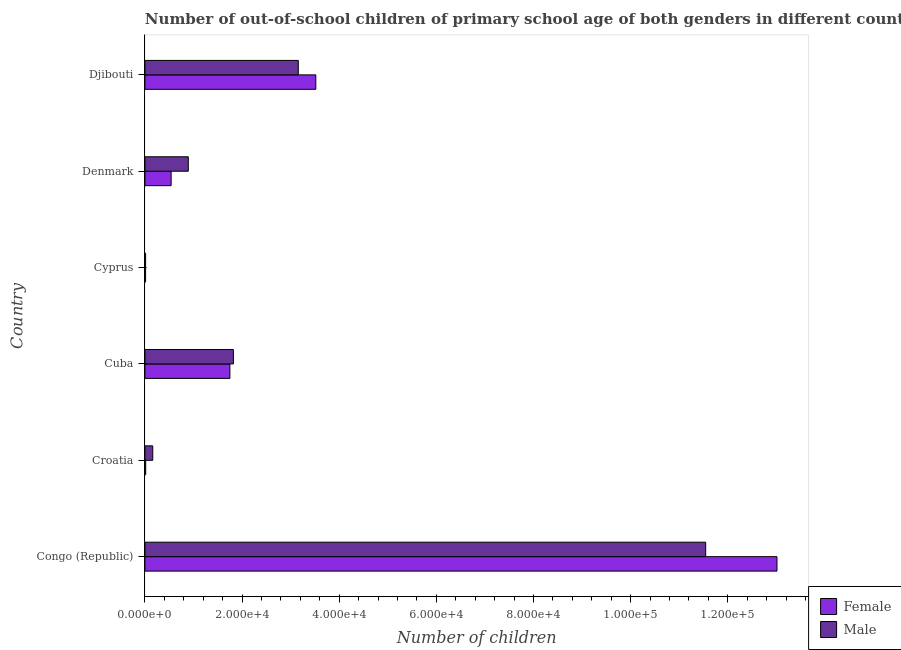How many groups of bars are there?
Provide a succinct answer. 6. Are the number of bars per tick equal to the number of legend labels?
Keep it short and to the point. Yes. What is the label of the 4th group of bars from the top?
Offer a terse response. Cuba. In how many cases, is the number of bars for a given country not equal to the number of legend labels?
Provide a short and direct response. 0. What is the number of female out-of-school students in Djibouti?
Keep it short and to the point. 3.52e+04. Across all countries, what is the maximum number of male out-of-school students?
Your answer should be compact. 1.15e+05. Across all countries, what is the minimum number of male out-of-school students?
Provide a short and direct response. 142. In which country was the number of male out-of-school students maximum?
Provide a succinct answer. Congo (Republic). In which country was the number of male out-of-school students minimum?
Your answer should be very brief. Cyprus. What is the total number of female out-of-school students in the graph?
Offer a very short reply. 1.89e+05. What is the difference between the number of male out-of-school students in Denmark and that in Djibouti?
Ensure brevity in your answer.  -2.26e+04. What is the difference between the number of male out-of-school students in Cyprus and the number of female out-of-school students in Congo (Republic)?
Ensure brevity in your answer.  -1.30e+05. What is the average number of female out-of-school students per country?
Provide a succinct answer. 3.14e+04. What is the difference between the number of female out-of-school students and number of male out-of-school students in Djibouti?
Offer a terse response. 3608. In how many countries, is the number of female out-of-school students greater than 100000 ?
Offer a very short reply. 1. What is the ratio of the number of male out-of-school students in Cuba to that in Cyprus?
Your answer should be compact. 128.3. What is the difference between the highest and the second highest number of female out-of-school students?
Your response must be concise. 9.50e+04. What is the difference between the highest and the lowest number of male out-of-school students?
Give a very brief answer. 1.15e+05. What does the 2nd bar from the bottom in Djibouti represents?
Offer a very short reply. Male. How many countries are there in the graph?
Ensure brevity in your answer.  6. What is the difference between two consecutive major ticks on the X-axis?
Give a very brief answer. 2.00e+04. Are the values on the major ticks of X-axis written in scientific E-notation?
Offer a terse response. Yes. Does the graph contain any zero values?
Your answer should be compact. No. Where does the legend appear in the graph?
Provide a succinct answer. Bottom right. How are the legend labels stacked?
Make the answer very short. Vertical. What is the title of the graph?
Make the answer very short. Number of out-of-school children of primary school age of both genders in different countries. What is the label or title of the X-axis?
Provide a short and direct response. Number of children. What is the label or title of the Y-axis?
Keep it short and to the point. Country. What is the Number of children in Female in Congo (Republic)?
Provide a short and direct response. 1.30e+05. What is the Number of children of Male in Congo (Republic)?
Ensure brevity in your answer.  1.15e+05. What is the Number of children in Female in Croatia?
Your answer should be very brief. 161. What is the Number of children of Male in Croatia?
Give a very brief answer. 1613. What is the Number of children of Female in Cuba?
Your answer should be very brief. 1.75e+04. What is the Number of children in Male in Cuba?
Give a very brief answer. 1.82e+04. What is the Number of children of Female in Cyprus?
Offer a very short reply. 138. What is the Number of children in Male in Cyprus?
Your answer should be very brief. 142. What is the Number of children of Female in Denmark?
Your answer should be compact. 5399. What is the Number of children in Male in Denmark?
Give a very brief answer. 8931. What is the Number of children of Female in Djibouti?
Ensure brevity in your answer.  3.52e+04. What is the Number of children in Male in Djibouti?
Make the answer very short. 3.16e+04. Across all countries, what is the maximum Number of children in Female?
Offer a terse response. 1.30e+05. Across all countries, what is the maximum Number of children of Male?
Ensure brevity in your answer.  1.15e+05. Across all countries, what is the minimum Number of children of Female?
Give a very brief answer. 138. Across all countries, what is the minimum Number of children of Male?
Give a very brief answer. 142. What is the total Number of children in Female in the graph?
Give a very brief answer. 1.89e+05. What is the total Number of children in Male in the graph?
Your answer should be very brief. 1.76e+05. What is the difference between the Number of children of Female in Congo (Republic) and that in Croatia?
Make the answer very short. 1.30e+05. What is the difference between the Number of children in Male in Congo (Republic) and that in Croatia?
Your answer should be very brief. 1.14e+05. What is the difference between the Number of children in Female in Congo (Republic) and that in Cuba?
Ensure brevity in your answer.  1.13e+05. What is the difference between the Number of children in Male in Congo (Republic) and that in Cuba?
Offer a terse response. 9.72e+04. What is the difference between the Number of children in Female in Congo (Republic) and that in Cyprus?
Your answer should be very brief. 1.30e+05. What is the difference between the Number of children in Male in Congo (Republic) and that in Cyprus?
Your answer should be compact. 1.15e+05. What is the difference between the Number of children in Female in Congo (Republic) and that in Denmark?
Give a very brief answer. 1.25e+05. What is the difference between the Number of children in Male in Congo (Republic) and that in Denmark?
Make the answer very short. 1.07e+05. What is the difference between the Number of children of Female in Congo (Republic) and that in Djibouti?
Your response must be concise. 9.50e+04. What is the difference between the Number of children of Male in Congo (Republic) and that in Djibouti?
Offer a terse response. 8.39e+04. What is the difference between the Number of children in Female in Croatia and that in Cuba?
Provide a short and direct response. -1.73e+04. What is the difference between the Number of children in Male in Croatia and that in Cuba?
Your answer should be compact. -1.66e+04. What is the difference between the Number of children of Female in Croatia and that in Cyprus?
Ensure brevity in your answer.  23. What is the difference between the Number of children in Male in Croatia and that in Cyprus?
Make the answer very short. 1471. What is the difference between the Number of children of Female in Croatia and that in Denmark?
Your response must be concise. -5238. What is the difference between the Number of children of Male in Croatia and that in Denmark?
Provide a short and direct response. -7318. What is the difference between the Number of children in Female in Croatia and that in Djibouti?
Your answer should be very brief. -3.50e+04. What is the difference between the Number of children of Male in Croatia and that in Djibouti?
Make the answer very short. -3.00e+04. What is the difference between the Number of children in Female in Cuba and that in Cyprus?
Your answer should be very brief. 1.74e+04. What is the difference between the Number of children in Male in Cuba and that in Cyprus?
Your answer should be compact. 1.81e+04. What is the difference between the Number of children in Female in Cuba and that in Denmark?
Offer a very short reply. 1.21e+04. What is the difference between the Number of children of Male in Cuba and that in Denmark?
Your response must be concise. 9288. What is the difference between the Number of children in Female in Cuba and that in Djibouti?
Ensure brevity in your answer.  -1.77e+04. What is the difference between the Number of children of Male in Cuba and that in Djibouti?
Offer a very short reply. -1.34e+04. What is the difference between the Number of children in Female in Cyprus and that in Denmark?
Make the answer very short. -5261. What is the difference between the Number of children in Male in Cyprus and that in Denmark?
Ensure brevity in your answer.  -8789. What is the difference between the Number of children in Female in Cyprus and that in Djibouti?
Offer a terse response. -3.51e+04. What is the difference between the Number of children in Male in Cyprus and that in Djibouti?
Your answer should be very brief. -3.14e+04. What is the difference between the Number of children in Female in Denmark and that in Djibouti?
Ensure brevity in your answer.  -2.98e+04. What is the difference between the Number of children of Male in Denmark and that in Djibouti?
Offer a terse response. -2.26e+04. What is the difference between the Number of children in Female in Congo (Republic) and the Number of children in Male in Croatia?
Your answer should be very brief. 1.29e+05. What is the difference between the Number of children of Female in Congo (Republic) and the Number of children of Male in Cuba?
Provide a succinct answer. 1.12e+05. What is the difference between the Number of children in Female in Congo (Republic) and the Number of children in Male in Cyprus?
Provide a succinct answer. 1.30e+05. What is the difference between the Number of children in Female in Congo (Republic) and the Number of children in Male in Denmark?
Your answer should be very brief. 1.21e+05. What is the difference between the Number of children in Female in Congo (Republic) and the Number of children in Male in Djibouti?
Give a very brief answer. 9.86e+04. What is the difference between the Number of children of Female in Croatia and the Number of children of Male in Cuba?
Provide a succinct answer. -1.81e+04. What is the difference between the Number of children of Female in Croatia and the Number of children of Male in Denmark?
Keep it short and to the point. -8770. What is the difference between the Number of children of Female in Croatia and the Number of children of Male in Djibouti?
Provide a short and direct response. -3.14e+04. What is the difference between the Number of children in Female in Cuba and the Number of children in Male in Cyprus?
Ensure brevity in your answer.  1.74e+04. What is the difference between the Number of children in Female in Cuba and the Number of children in Male in Denmark?
Your response must be concise. 8566. What is the difference between the Number of children of Female in Cuba and the Number of children of Male in Djibouti?
Offer a very short reply. -1.41e+04. What is the difference between the Number of children of Female in Cyprus and the Number of children of Male in Denmark?
Your answer should be compact. -8793. What is the difference between the Number of children of Female in Cyprus and the Number of children of Male in Djibouti?
Keep it short and to the point. -3.14e+04. What is the difference between the Number of children in Female in Denmark and the Number of children in Male in Djibouti?
Your answer should be very brief. -2.62e+04. What is the average Number of children of Female per country?
Your answer should be compact. 3.14e+04. What is the average Number of children in Male per country?
Offer a very short reply. 2.93e+04. What is the difference between the Number of children of Female and Number of children of Male in Congo (Republic)?
Provide a succinct answer. 1.47e+04. What is the difference between the Number of children of Female and Number of children of Male in Croatia?
Your response must be concise. -1452. What is the difference between the Number of children in Female and Number of children in Male in Cuba?
Give a very brief answer. -722. What is the difference between the Number of children of Female and Number of children of Male in Cyprus?
Offer a terse response. -4. What is the difference between the Number of children in Female and Number of children in Male in Denmark?
Offer a very short reply. -3532. What is the difference between the Number of children of Female and Number of children of Male in Djibouti?
Offer a very short reply. 3608. What is the ratio of the Number of children of Female in Congo (Republic) to that in Croatia?
Your answer should be compact. 808.35. What is the ratio of the Number of children in Male in Congo (Republic) to that in Croatia?
Give a very brief answer. 71.58. What is the ratio of the Number of children in Female in Congo (Republic) to that in Cuba?
Ensure brevity in your answer.  7.44. What is the ratio of the Number of children of Male in Congo (Republic) to that in Cuba?
Offer a very short reply. 6.34. What is the ratio of the Number of children of Female in Congo (Republic) to that in Cyprus?
Offer a terse response. 943.07. What is the ratio of the Number of children of Male in Congo (Republic) to that in Cyprus?
Ensure brevity in your answer.  813.13. What is the ratio of the Number of children in Female in Congo (Republic) to that in Denmark?
Your answer should be very brief. 24.11. What is the ratio of the Number of children of Male in Congo (Republic) to that in Denmark?
Offer a very short reply. 12.93. What is the ratio of the Number of children of Female in Congo (Republic) to that in Djibouti?
Keep it short and to the point. 3.7. What is the ratio of the Number of children of Male in Congo (Republic) to that in Djibouti?
Your answer should be compact. 3.66. What is the ratio of the Number of children in Female in Croatia to that in Cuba?
Provide a succinct answer. 0.01. What is the ratio of the Number of children in Male in Croatia to that in Cuba?
Make the answer very short. 0.09. What is the ratio of the Number of children in Male in Croatia to that in Cyprus?
Provide a short and direct response. 11.36. What is the ratio of the Number of children in Female in Croatia to that in Denmark?
Offer a terse response. 0.03. What is the ratio of the Number of children in Male in Croatia to that in Denmark?
Offer a terse response. 0.18. What is the ratio of the Number of children of Female in Croatia to that in Djibouti?
Provide a short and direct response. 0. What is the ratio of the Number of children in Male in Croatia to that in Djibouti?
Your answer should be compact. 0.05. What is the ratio of the Number of children of Female in Cuba to that in Cyprus?
Make the answer very short. 126.79. What is the ratio of the Number of children in Male in Cuba to that in Cyprus?
Provide a succinct answer. 128.3. What is the ratio of the Number of children of Female in Cuba to that in Denmark?
Provide a short and direct response. 3.24. What is the ratio of the Number of children of Male in Cuba to that in Denmark?
Provide a short and direct response. 2.04. What is the ratio of the Number of children of Female in Cuba to that in Djibouti?
Give a very brief answer. 0.5. What is the ratio of the Number of children of Male in Cuba to that in Djibouti?
Your answer should be very brief. 0.58. What is the ratio of the Number of children in Female in Cyprus to that in Denmark?
Your response must be concise. 0.03. What is the ratio of the Number of children in Male in Cyprus to that in Denmark?
Offer a terse response. 0.02. What is the ratio of the Number of children of Female in Cyprus to that in Djibouti?
Ensure brevity in your answer.  0. What is the ratio of the Number of children of Male in Cyprus to that in Djibouti?
Offer a terse response. 0. What is the ratio of the Number of children in Female in Denmark to that in Djibouti?
Provide a short and direct response. 0.15. What is the ratio of the Number of children in Male in Denmark to that in Djibouti?
Provide a short and direct response. 0.28. What is the difference between the highest and the second highest Number of children of Female?
Make the answer very short. 9.50e+04. What is the difference between the highest and the second highest Number of children of Male?
Keep it short and to the point. 8.39e+04. What is the difference between the highest and the lowest Number of children in Female?
Make the answer very short. 1.30e+05. What is the difference between the highest and the lowest Number of children in Male?
Offer a terse response. 1.15e+05. 